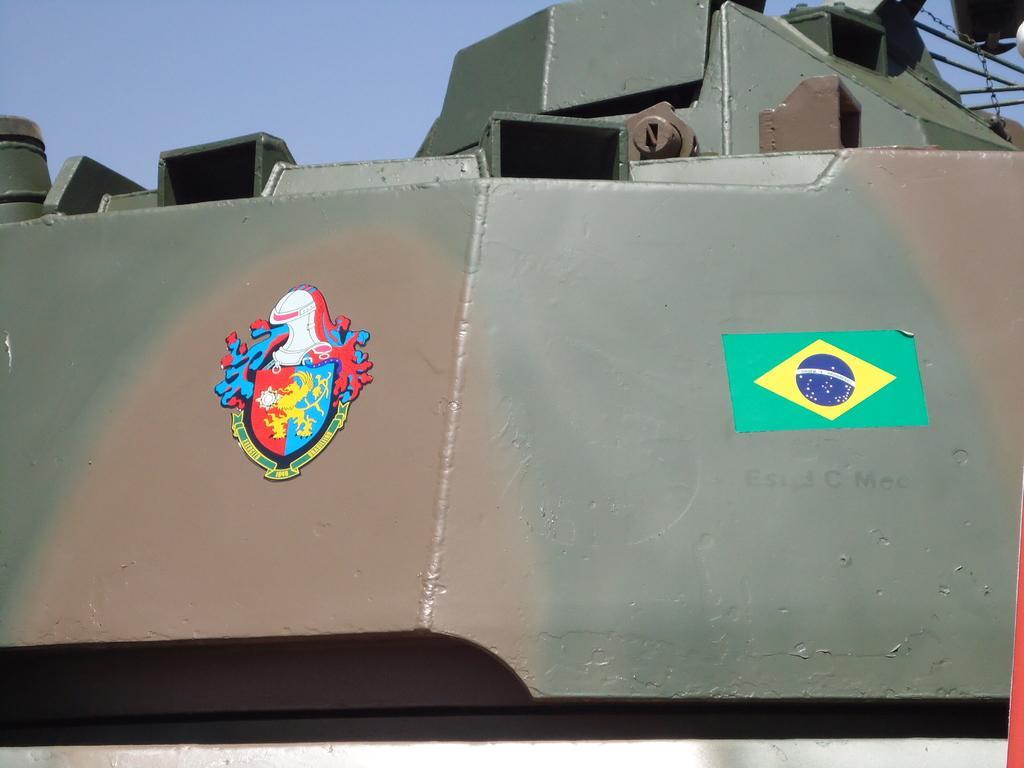How would you summarize this image in a sentence or two? In this image there are metal objects, stickers and blue sky. 